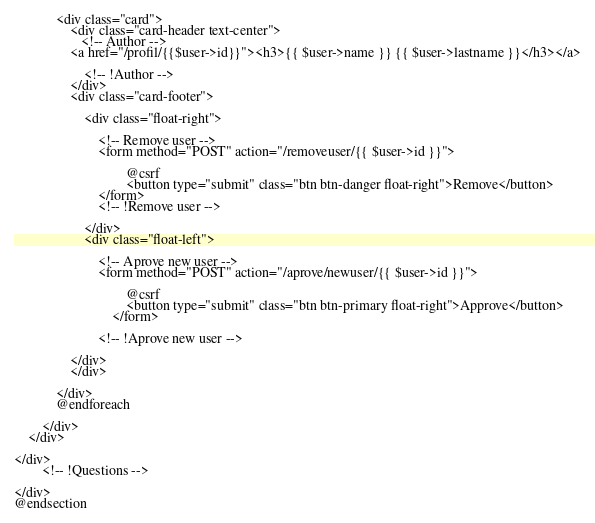Convert code to text. <code><loc_0><loc_0><loc_500><loc_500><_PHP_>            <div class="card">
                <div class="card-header text-center">
                   <!-- Author -->
                <a href="/profil/{{$user->id}}"><h3>{{ $user->name }} {{ $user->lastname }}</h3></a>

                    <!-- !Author -->
                </div>
                <div class="card-footer">

                    <div class="float-right">

                        <!-- Remove user -->
                        <form method="POST" action="/removeuser/{{ $user->id }}">

                                @csrf
                                <button type="submit" class="btn btn-danger float-right">Remove</button>
                        </form>
                        <!-- !Remove user -->

                    </div>
                    <div class="float-left">

                        <!-- Aprove new user -->
                        <form method="POST" action="/aprove/newuser/{{ $user->id }}">

                                @csrf
                                <button type="submit" class="btn btn-primary float-right">Approve</button>
                            </form>

                        <!-- !Aprove new user -->

                </div>
                </div>

            </div>
            @endforeach

        </div>
    </div>

</div>
        <!-- !Questions -->

</div>
@endsection
</code> 